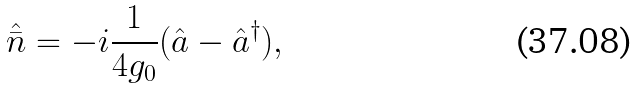Convert formula to latex. <formula><loc_0><loc_0><loc_500><loc_500>\hat { \bar { n } } = - i \frac { 1 } { 4 g _ { 0 } } ( \hat { a } - \hat { a } ^ { \dagger } ) ,</formula> 